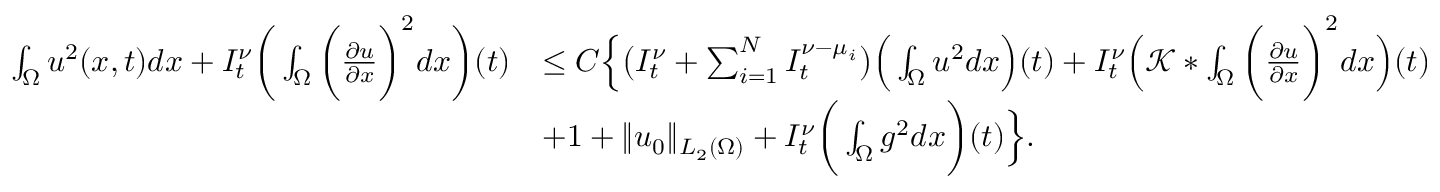Convert formula to latex. <formula><loc_0><loc_0><loc_500><loc_500>\begin{array} { r l } { \int _ { \Omega } u ^ { 2 } ( x , t ) d x + I _ { t } ^ { \nu } \left ( \int _ { \Omega } \left ( \frac { \partial u } { \partial x } \right ) ^ { 2 } d x \right ) ( t ) } & { \leq C \left \{ \left ( I _ { t } ^ { \nu } + \sum _ { i = 1 } ^ { N } I _ { t } ^ { \nu - \mu _ { i } } \right ) \left ( \int _ { \Omega } u ^ { 2 } d x \right ) ( t ) + I _ { t } ^ { \nu } \left ( \mathcal { K } * \int _ { \Omega } \left ( \frac { \partial u } { \partial x } \right ) ^ { 2 } d x \right ) ( t ) } \\ & { + 1 + \| u _ { 0 } \| _ { L _ { 2 } ( \Omega ) } + I _ { t } ^ { \nu } \left ( \int _ { \Omega } g ^ { 2 } d x \right ) ( t ) \right \} . } \end{array}</formula> 